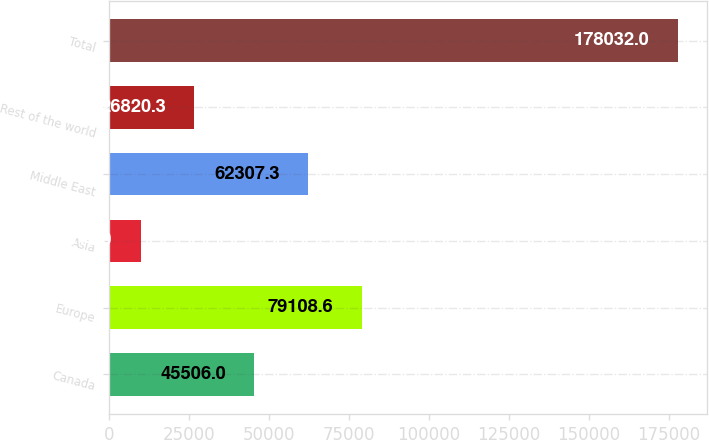Convert chart to OTSL. <chart><loc_0><loc_0><loc_500><loc_500><bar_chart><fcel>Canada<fcel>Europe<fcel>Asia<fcel>Middle East<fcel>Rest of the world<fcel>Total<nl><fcel>45506<fcel>79108.6<fcel>10019<fcel>62307.3<fcel>26820.3<fcel>178032<nl></chart> 